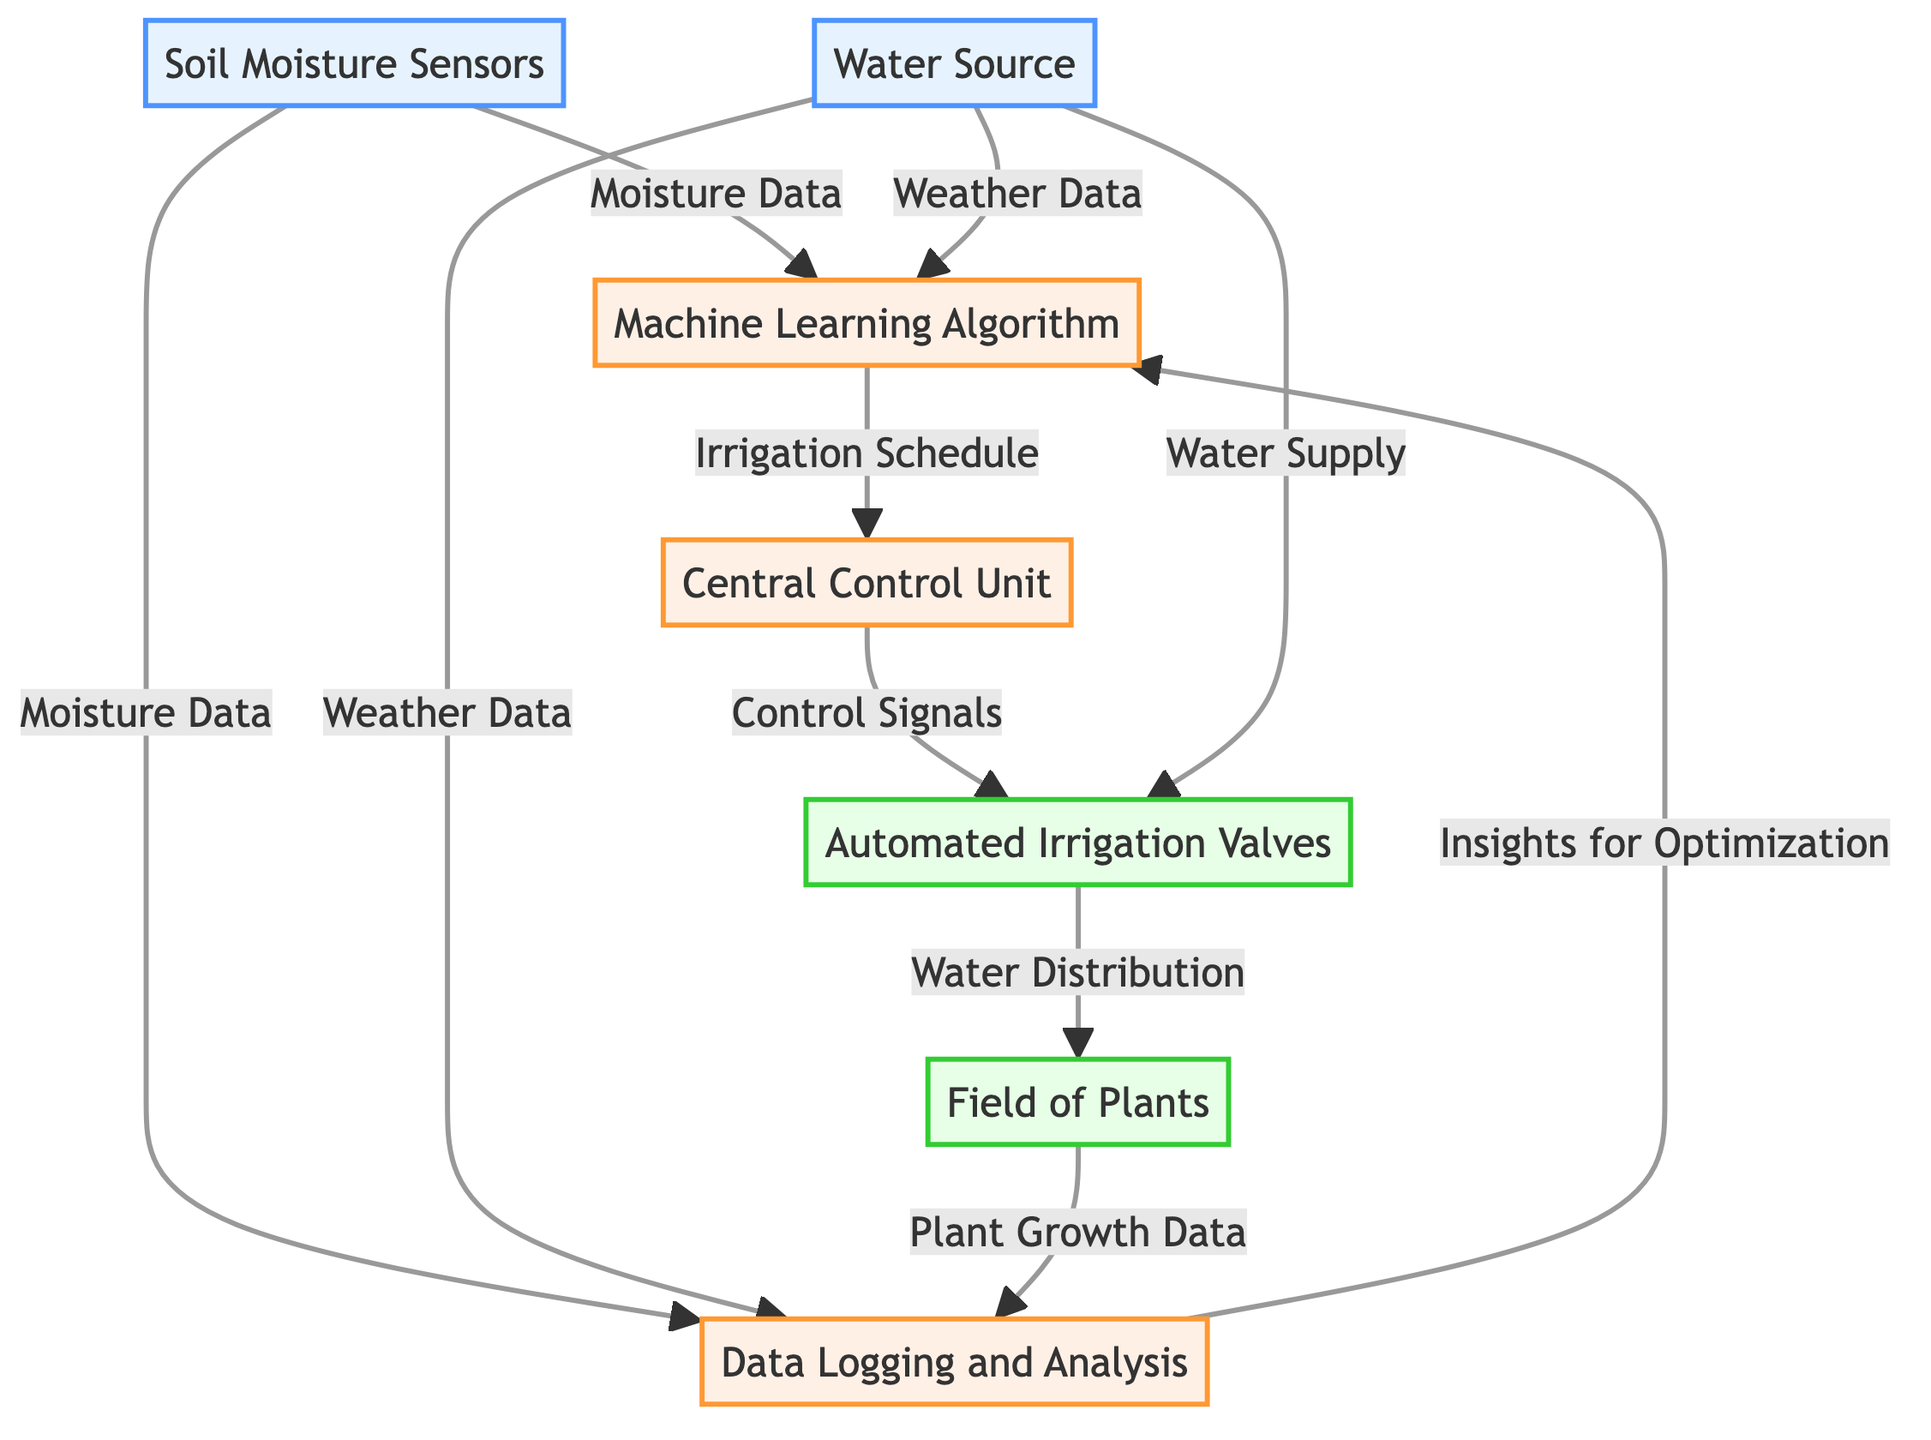What are the inputs to the Machine Learning Algorithm? The inputs to the Machine Learning Algorithm are Moisture Data and Weather Data, which are derived from the Soil Moisture Sensors and Weather Station respectively.
Answer: Moisture Data, Weather Data What does the Central Control Unit output? The Central Control Unit processes the Irrigation Schedule and outputs Control Signals to the Automated Irrigation Valves.
Answer: Control Signals How many sensors are depicted in the diagram? There are two sensors depicted in the diagram: Soil Moisture Sensors and Weather Station.
Answer: 2 What is the role of Data Logging and Analysis? The role of Data Logging and Analysis is to store historical data and analyze the performance of irrigation, which helps in providing insights for optimization.
Answer: Insights for Optimization Which component receives both Moisture Data and Weather Data? The Machine Learning Algorithm receives both Moisture Data (from the Soil Moisture Sensors) and Weather Data (from the Weather Station) for processing to predict the irrigation schedule.
Answer: Machine Learning Algorithm How does the Water Source influence the Automated Irrigation Valves? The Water Source provides the Water Supply, which is necessary for the Automated Irrigation Valves to distribute water based on the Control Signals received from the Central Control Unit.
Answer: Water Supply What is the final output of the automated irrigation system? The final output of the automated irrigation system is Plant Growth Data, which is influenced by the Water Distribution.
Answer: Plant Growth Data What kind of data is used to improve the Machine Learning Algorithm? The insights generated from the Data Logging and Analysis are used to improve the Machine Learning Algorithm, making it more efficient in predicting the optimal irrigation schedule.
Answer: Insights for Optimization Which component manages water flow automatically? The Automated Irrigation Valves manage water flow automatically based on the Control Signals received from the Central Control Unit.
Answer: Automated Irrigation Valves 